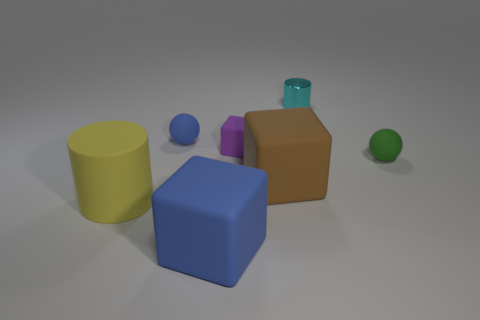There is a cylinder behind the tiny rubber ball on the right side of the tiny rubber ball to the left of the small cyan metallic cylinder; what is its size?
Offer a very short reply. Small. How big is the matte ball on the right side of the tiny blue sphere?
Ensure brevity in your answer.  Small. Is the brown thing the same shape as the purple thing?
Provide a short and direct response. Yes. What number of other things are there of the same size as the yellow matte thing?
Offer a terse response. 2. How many things are large rubber blocks that are in front of the big brown rubber thing or big brown things?
Your response must be concise. 2. What color is the rubber cylinder?
Your answer should be compact. Yellow. There is a tiny sphere to the right of the cyan cylinder; what is its material?
Give a very brief answer. Rubber. There is a tiny blue object; is its shape the same as the small thing that is behind the blue ball?
Your response must be concise. No. Is the number of small cyan shiny cylinders greater than the number of tiny brown things?
Keep it short and to the point. Yes. Is there any other thing that has the same color as the big rubber cylinder?
Your answer should be compact. No. 